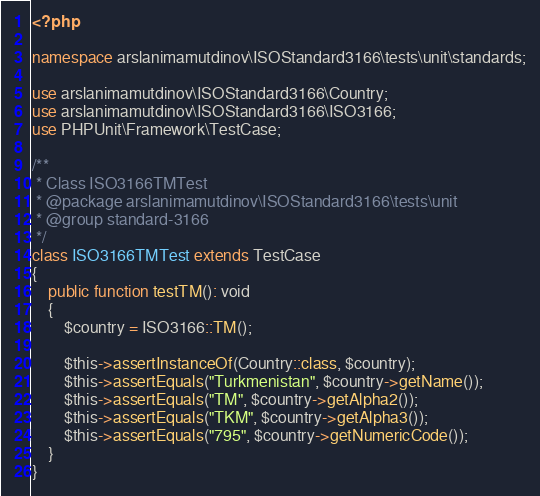Convert code to text. <code><loc_0><loc_0><loc_500><loc_500><_PHP_><?php

namespace arslanimamutdinov\ISOStandard3166\tests\unit\standards;

use arslanimamutdinov\ISOStandard3166\Country;
use arslanimamutdinov\ISOStandard3166\ISO3166;
use PHPUnit\Framework\TestCase;

/**
 * Class ISO3166TMTest
 * @package arslanimamutdinov\ISOStandard3166\tests\unit
 * @group standard-3166
 */
class ISO3166TMTest extends TestCase
{
    public function testTM(): void
    {
        $country = ISO3166::TM();

        $this->assertInstanceOf(Country::class, $country);
        $this->assertEquals("Turkmenistan", $country->getName());
        $this->assertEquals("TM", $country->getAlpha2());
        $this->assertEquals("TKM", $country->getAlpha3());
        $this->assertEquals("795", $country->getNumericCode());
    }
}
</code> 